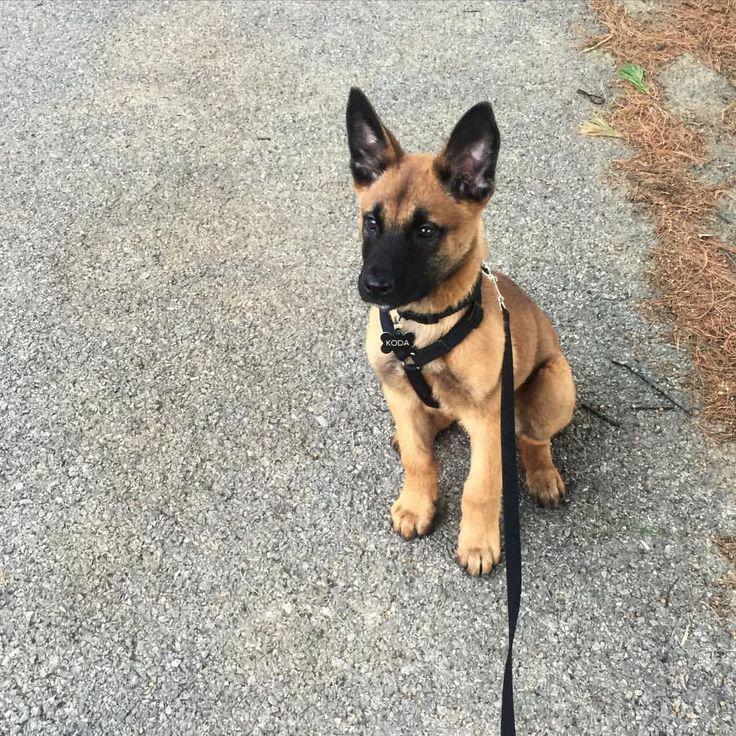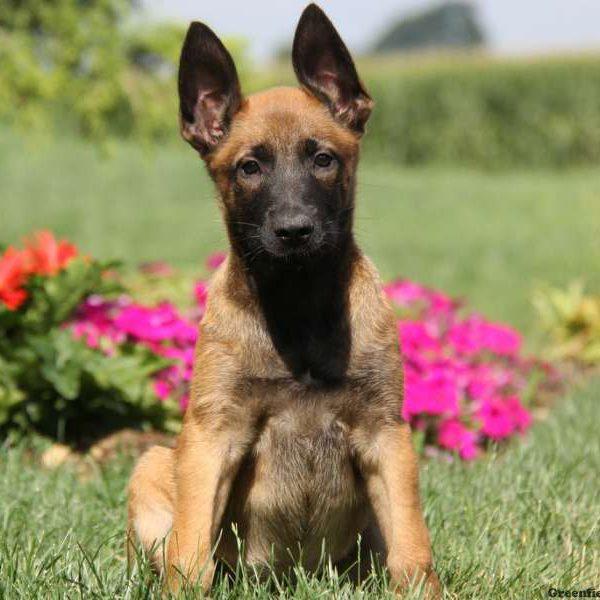The first image is the image on the left, the second image is the image on the right. Evaluate the accuracy of this statement regarding the images: "One of the dogs is on a leash.". Is it true? Answer yes or no. Yes. 